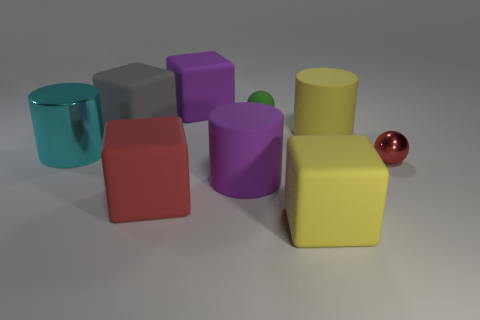Subtract 1 cubes. How many cubes are left? 3 Add 1 small red cylinders. How many objects exist? 10 Subtract all blocks. How many objects are left? 5 Subtract all tiny shiny things. Subtract all tiny green metal objects. How many objects are left? 8 Add 3 green rubber objects. How many green rubber objects are left? 4 Add 5 big gray blocks. How many big gray blocks exist? 6 Subtract 0 gray spheres. How many objects are left? 9 